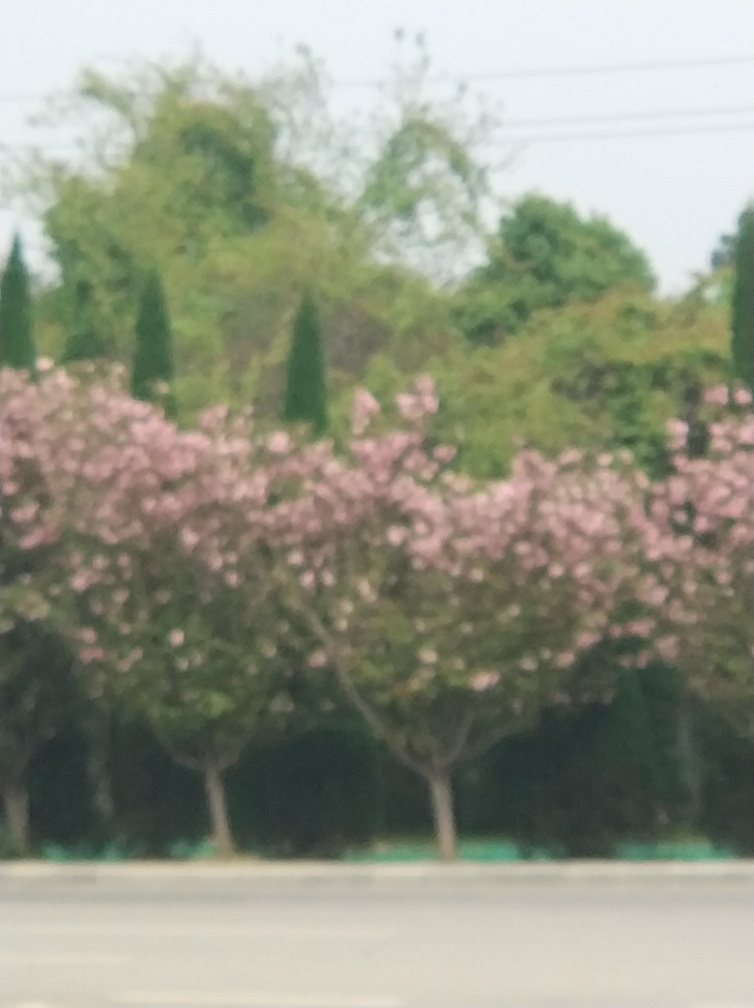What type of trees are those with pink blossoms in the image? The trees with pink blossoms resemble cherry blossom trees, also known as Sakura, which are widely appreciated for their beauty during the blooming season. 